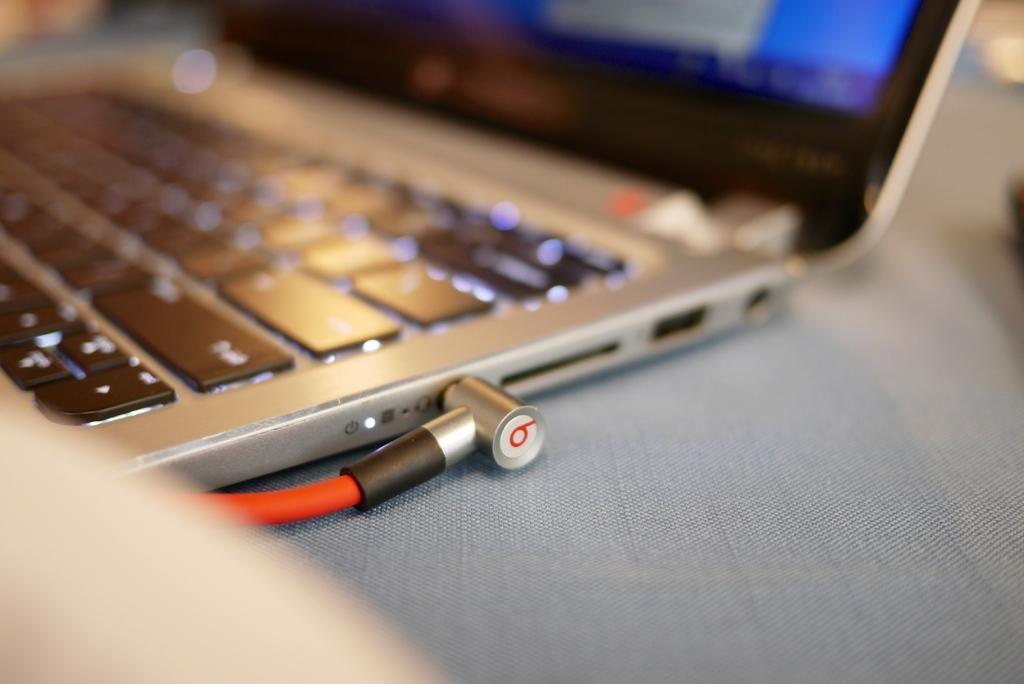<image>
Create a compact narrative representing the image presented. The wire connected to the computer is labeled with the number 6. 